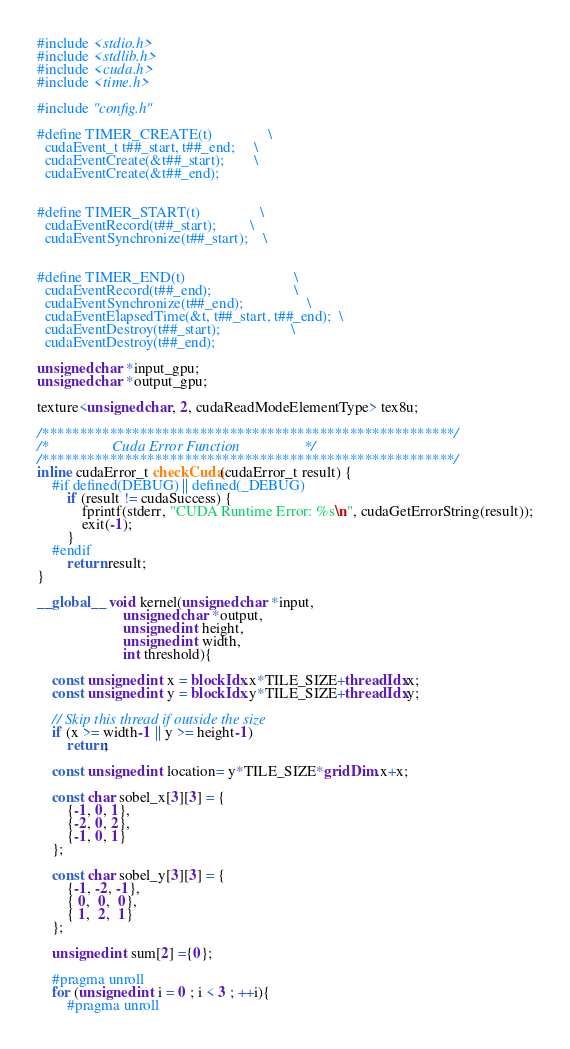<code> <loc_0><loc_0><loc_500><loc_500><_Cuda_>
#include <stdio.h>
#include <stdlib.h>
#include <cuda.h>
#include <time.h>

#include "config.h"

#define TIMER_CREATE(t)               \
  cudaEvent_t t##_start, t##_end;     \
  cudaEventCreate(&t##_start);        \
  cudaEventCreate(&t##_end);               
 
 
#define TIMER_START(t)                \
  cudaEventRecord(t##_start);         \
  cudaEventSynchronize(t##_start);    \
 
 
#define TIMER_END(t)                             \
  cudaEventRecord(t##_end);                      \
  cudaEventSynchronize(t##_end);                 \
  cudaEventElapsedTime(&t, t##_start, t##_end);  \
  cudaEventDestroy(t##_start);                   \
  cudaEventDestroy(t##_end);     
  
unsigned char *input_gpu;
unsigned char *output_gpu;

texture<unsigned char, 2, cudaReadModeElementType> tex8u;

/*******************************************************/
/*                 Cuda Error Function                 */
/*******************************************************/
inline cudaError_t checkCuda(cudaError_t result) {
	#if defined(DEBUG) || defined(_DEBUG)
		if (result != cudaSuccess) {
			fprintf(stderr, "CUDA Runtime Error: %s\n", cudaGetErrorString(result));
			exit(-1);
		}
	#endif
		return result;
}

__global__ void kernel(unsigned char *input, 
                       unsigned char *output,
                       unsigned int height, 
                       unsigned int width,
                       int threshold){

    const unsigned int x = blockIdx.x*TILE_SIZE+threadIdx.x;
    const unsigned int y = blockIdx.y*TILE_SIZE+threadIdx.y;
    
    // Skip this thread if outside the size
    if (x >= width-1 || y >= height-1)
        return;

    const unsigned int location= y*TILE_SIZE*gridDim.x+x;

    const char sobel_x[3][3] = {
        {-1, 0, 1},
        {-2, 0, 2},
        {-1, 0, 1}
    };

    const char sobel_y[3][3] = {
        {-1, -2, -1},
        { 0,  0,  0},
        { 1,  2,  1}
    };	

    unsigned int sum[2] ={0};

    #pragma unroll
    for (unsigned int i = 0 ; i < 3 ; ++i){
        #pragma unroll</code> 